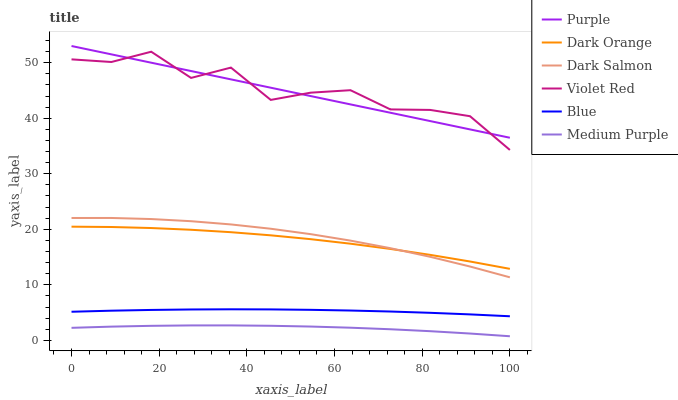Does Medium Purple have the minimum area under the curve?
Answer yes or no. Yes. Does Violet Red have the maximum area under the curve?
Answer yes or no. Yes. Does Dark Orange have the minimum area under the curve?
Answer yes or no. No. Does Dark Orange have the maximum area under the curve?
Answer yes or no. No. Is Purple the smoothest?
Answer yes or no. Yes. Is Violet Red the roughest?
Answer yes or no. Yes. Is Dark Orange the smoothest?
Answer yes or no. No. Is Dark Orange the roughest?
Answer yes or no. No. Does Medium Purple have the lowest value?
Answer yes or no. Yes. Does Dark Orange have the lowest value?
Answer yes or no. No. Does Purple have the highest value?
Answer yes or no. Yes. Does Dark Orange have the highest value?
Answer yes or no. No. Is Blue less than Purple?
Answer yes or no. Yes. Is Purple greater than Medium Purple?
Answer yes or no. Yes. Does Dark Salmon intersect Dark Orange?
Answer yes or no. Yes. Is Dark Salmon less than Dark Orange?
Answer yes or no. No. Is Dark Salmon greater than Dark Orange?
Answer yes or no. No. Does Blue intersect Purple?
Answer yes or no. No. 